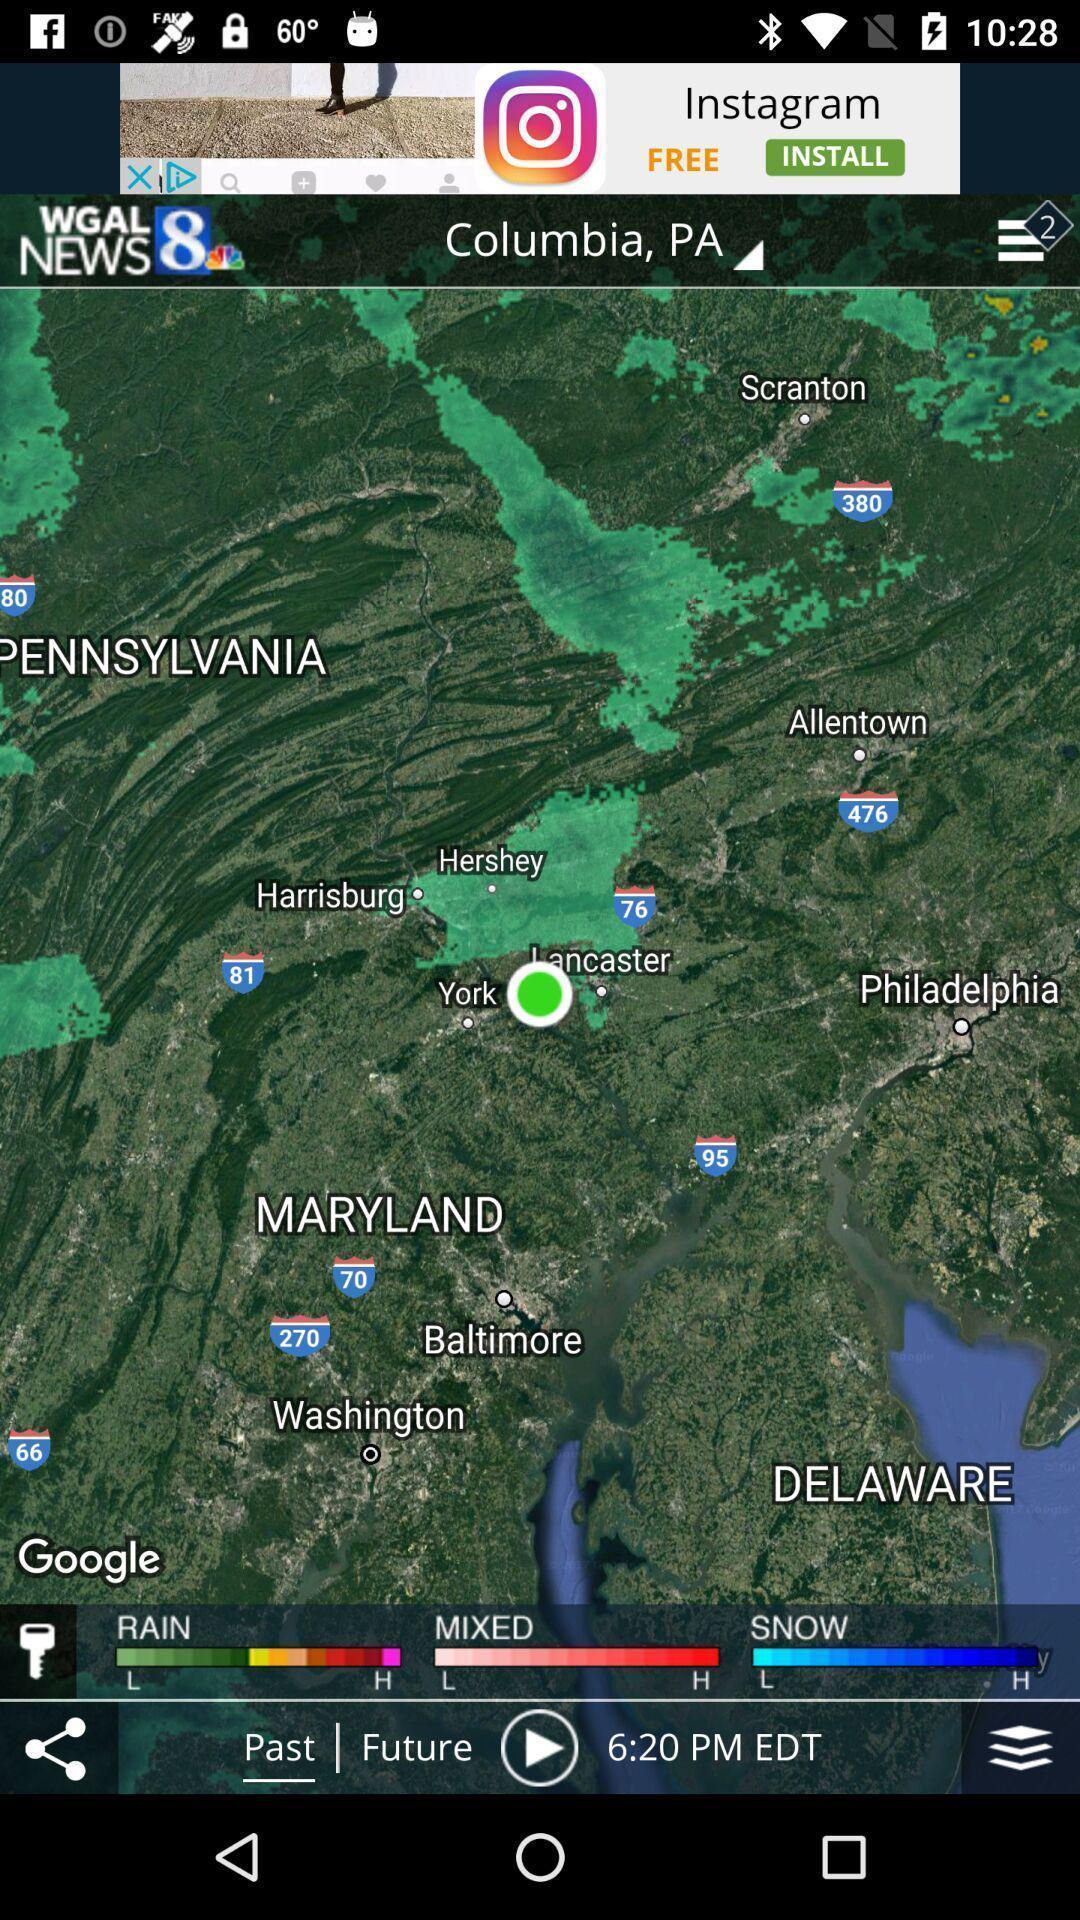Describe the key features of this screenshot. Screen showing weather report. 